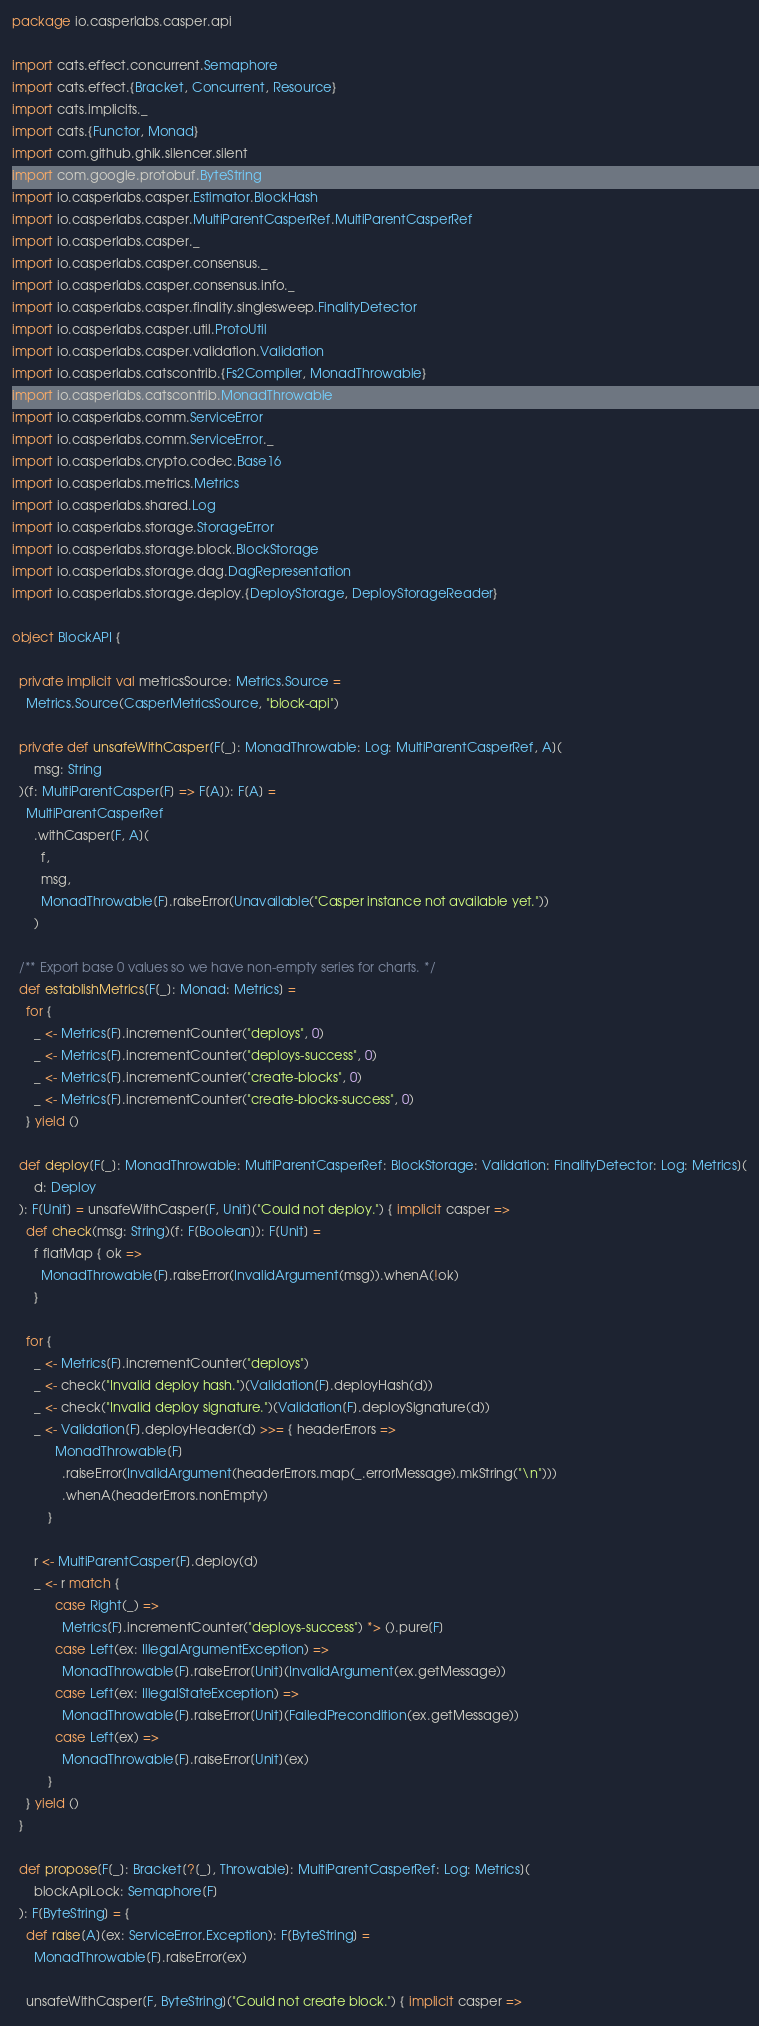Convert code to text. <code><loc_0><loc_0><loc_500><loc_500><_Scala_>package io.casperlabs.casper.api

import cats.effect.concurrent.Semaphore
import cats.effect.{Bracket, Concurrent, Resource}
import cats.implicits._
import cats.{Functor, Monad}
import com.github.ghik.silencer.silent
import com.google.protobuf.ByteString
import io.casperlabs.casper.Estimator.BlockHash
import io.casperlabs.casper.MultiParentCasperRef.MultiParentCasperRef
import io.casperlabs.casper._
import io.casperlabs.casper.consensus._
import io.casperlabs.casper.consensus.info._
import io.casperlabs.casper.finality.singlesweep.FinalityDetector
import io.casperlabs.casper.util.ProtoUtil
import io.casperlabs.casper.validation.Validation
import io.casperlabs.catscontrib.{Fs2Compiler, MonadThrowable}
import io.casperlabs.catscontrib.MonadThrowable
import io.casperlabs.comm.ServiceError
import io.casperlabs.comm.ServiceError._
import io.casperlabs.crypto.codec.Base16
import io.casperlabs.metrics.Metrics
import io.casperlabs.shared.Log
import io.casperlabs.storage.StorageError
import io.casperlabs.storage.block.BlockStorage
import io.casperlabs.storage.dag.DagRepresentation
import io.casperlabs.storage.deploy.{DeployStorage, DeployStorageReader}

object BlockAPI {

  private implicit val metricsSource: Metrics.Source =
    Metrics.Source(CasperMetricsSource, "block-api")

  private def unsafeWithCasper[F[_]: MonadThrowable: Log: MultiParentCasperRef, A](
      msg: String
  )(f: MultiParentCasper[F] => F[A]): F[A] =
    MultiParentCasperRef
      .withCasper[F, A](
        f,
        msg,
        MonadThrowable[F].raiseError(Unavailable("Casper instance not available yet."))
      )

  /** Export base 0 values so we have non-empty series for charts. */
  def establishMetrics[F[_]: Monad: Metrics] =
    for {
      _ <- Metrics[F].incrementCounter("deploys", 0)
      _ <- Metrics[F].incrementCounter("deploys-success", 0)
      _ <- Metrics[F].incrementCounter("create-blocks", 0)
      _ <- Metrics[F].incrementCounter("create-blocks-success", 0)
    } yield ()

  def deploy[F[_]: MonadThrowable: MultiParentCasperRef: BlockStorage: Validation: FinalityDetector: Log: Metrics](
      d: Deploy
  ): F[Unit] = unsafeWithCasper[F, Unit]("Could not deploy.") { implicit casper =>
    def check(msg: String)(f: F[Boolean]): F[Unit] =
      f flatMap { ok =>
        MonadThrowable[F].raiseError(InvalidArgument(msg)).whenA(!ok)
      }

    for {
      _ <- Metrics[F].incrementCounter("deploys")
      _ <- check("Invalid deploy hash.")(Validation[F].deployHash(d))
      _ <- check("Invalid deploy signature.")(Validation[F].deploySignature(d))
      _ <- Validation[F].deployHeader(d) >>= { headerErrors =>
            MonadThrowable[F]
              .raiseError(InvalidArgument(headerErrors.map(_.errorMessage).mkString("\n")))
              .whenA(headerErrors.nonEmpty)
          }

      r <- MultiParentCasper[F].deploy(d)
      _ <- r match {
            case Right(_) =>
              Metrics[F].incrementCounter("deploys-success") *> ().pure[F]
            case Left(ex: IllegalArgumentException) =>
              MonadThrowable[F].raiseError[Unit](InvalidArgument(ex.getMessage))
            case Left(ex: IllegalStateException) =>
              MonadThrowable[F].raiseError[Unit](FailedPrecondition(ex.getMessage))
            case Left(ex) =>
              MonadThrowable[F].raiseError[Unit](ex)
          }
    } yield ()
  }

  def propose[F[_]: Bracket[?[_], Throwable]: MultiParentCasperRef: Log: Metrics](
      blockApiLock: Semaphore[F]
  ): F[ByteString] = {
    def raise[A](ex: ServiceError.Exception): F[ByteString] =
      MonadThrowable[F].raiseError(ex)

    unsafeWithCasper[F, ByteString]("Could not create block.") { implicit casper =></code> 